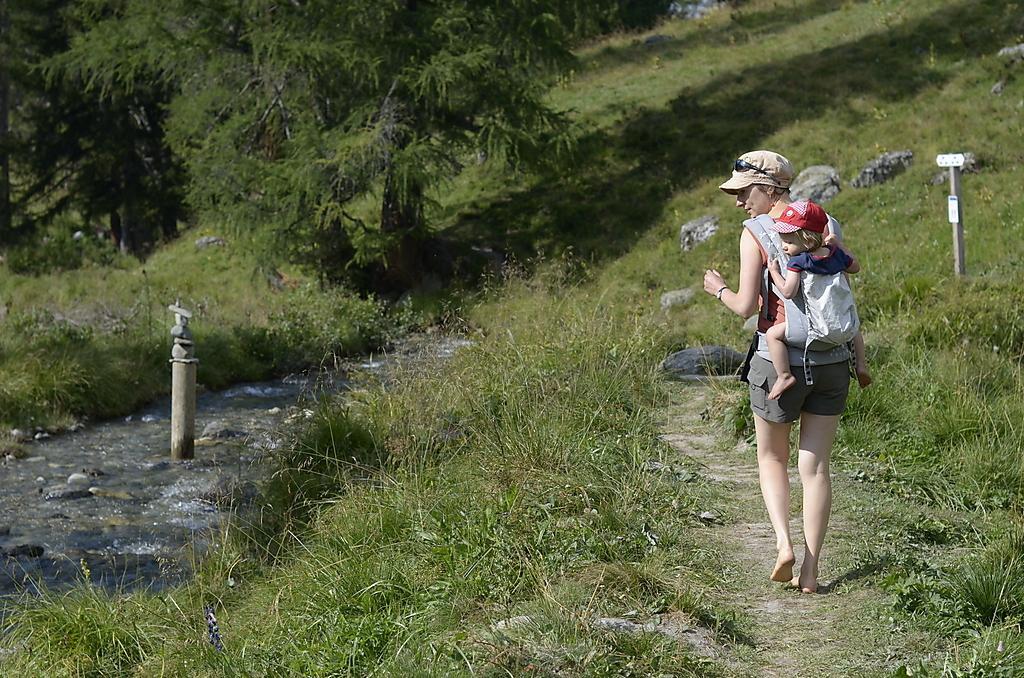Please provide a concise description of this image. In this image I can see the two people with different color dresses and caps. On both sides I can see the grass and the poles. To the left I can see the water. In the background I can see the trees. 